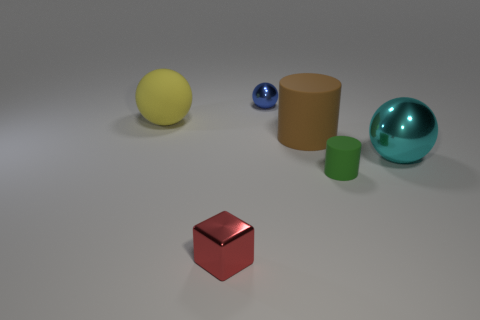Subtract all yellow cylinders. Subtract all purple balls. How many cylinders are left? 2 Add 3 metallic things. How many objects exist? 9 Subtract all cylinders. How many objects are left? 4 Add 3 tiny blue things. How many tiny blue things are left? 4 Add 5 cubes. How many cubes exist? 6 Subtract 0 gray cylinders. How many objects are left? 6 Subtract all large blue matte objects. Subtract all small green rubber objects. How many objects are left? 5 